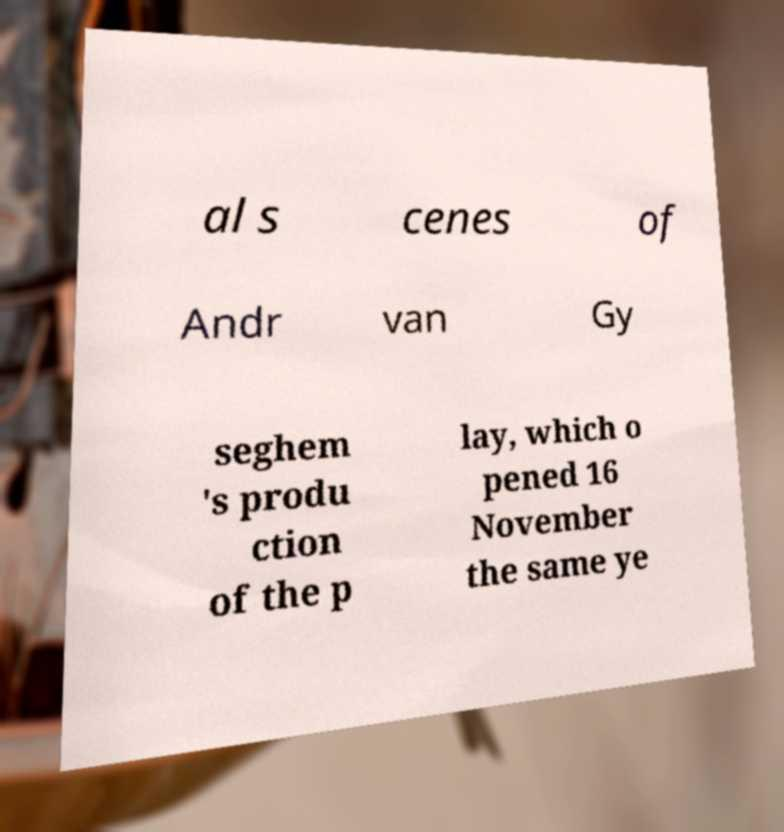I need the written content from this picture converted into text. Can you do that? al s cenes of Andr van Gy seghem 's produ ction of the p lay, which o pened 16 November the same ye 